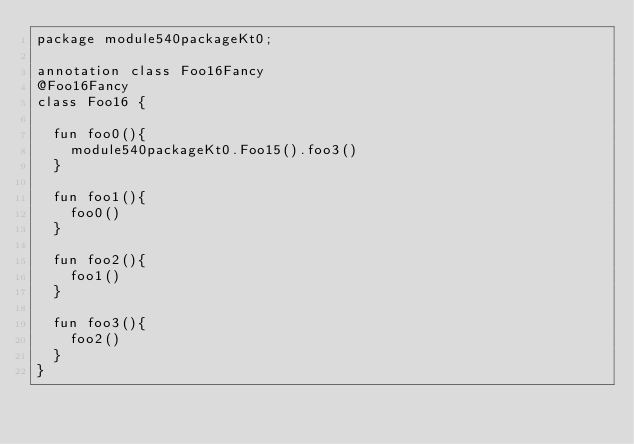<code> <loc_0><loc_0><loc_500><loc_500><_Kotlin_>package module540packageKt0;

annotation class Foo16Fancy
@Foo16Fancy
class Foo16 {

  fun foo0(){
    module540packageKt0.Foo15().foo3()
  }

  fun foo1(){
    foo0()
  }

  fun foo2(){
    foo1()
  }

  fun foo3(){
    foo2()
  }
}</code> 